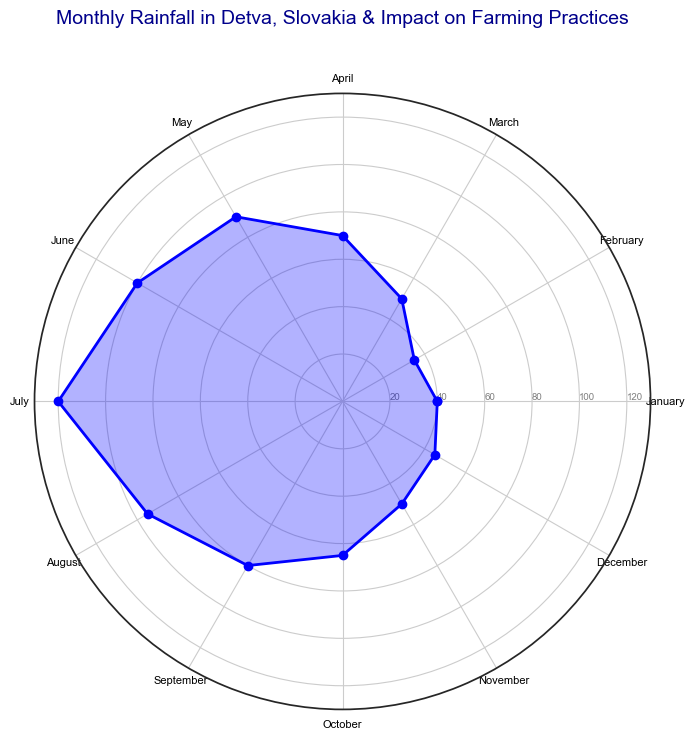What month has the highest rainfall? Look at the length of the bar markers on the chart. The month with the longest bar corresponds to July, which has the highest rainfall.
Answer: July What is the total rainfall during the first quarter of the year (January to March)? Sum the monthly rainfall values for January, February, and March. That will be 40 mm + 35 mm + 50 mm, giving a total of 125 mm.
Answer: 125 mm In which month does the critical growth period for most crops begin? The critical growth period for most crops starts in June, as indicated by the agricultural practice associated with this month.
Answer: June Which months have an impact labeled as "Minimal impact; fields are usually at rest"? Look for the months with this label in the impact on farming practices part. These months are January, February, November, and December.
Answer: January, February, November, December How much more rainfall is there in July compared to December? Subtract the rainfall in December from the rainfall in July. July has 120 mm and December has 45 mm, so the difference is 120 mm - 45 mm = 75 mm.
Answer: 75 mm What is the month with the least rainfall and what is its impact on farming practices? The month with the least rainfall is February with 35 mm. Its impact on farming practices is labelled as minimal impact; fields are usually at rest.
Answer: February; Minimal impact; fields are usually at rest What is the average monthly rainfall over the entire year? Sum the monthly rainfall values (40 + 35 + 50 + 70 + 90 + 100 + 120 + 95 + 80 + 65 + 50 + 45 = 840 mm). Divide by 12 months to get the average: 840 mm / 12 = 70 mm.
Answer: 70 mm How does the rainfall in May compare to that in April and June? Compare the bar lengths for May, April, and June. May has 90 mm of rainfall, April has 70 mm, and June has 100 mm. Therefore, May's rainfall is greater than April's but less than June's.
Answer: Greater than April, less than June What months would be the least impacted if there was a significant decrease in rainfall? Based on the "Minimal impact" labels from the farming practices section, the least impacted months would be January, February, November, and December.
Answer: January, February, November, December 